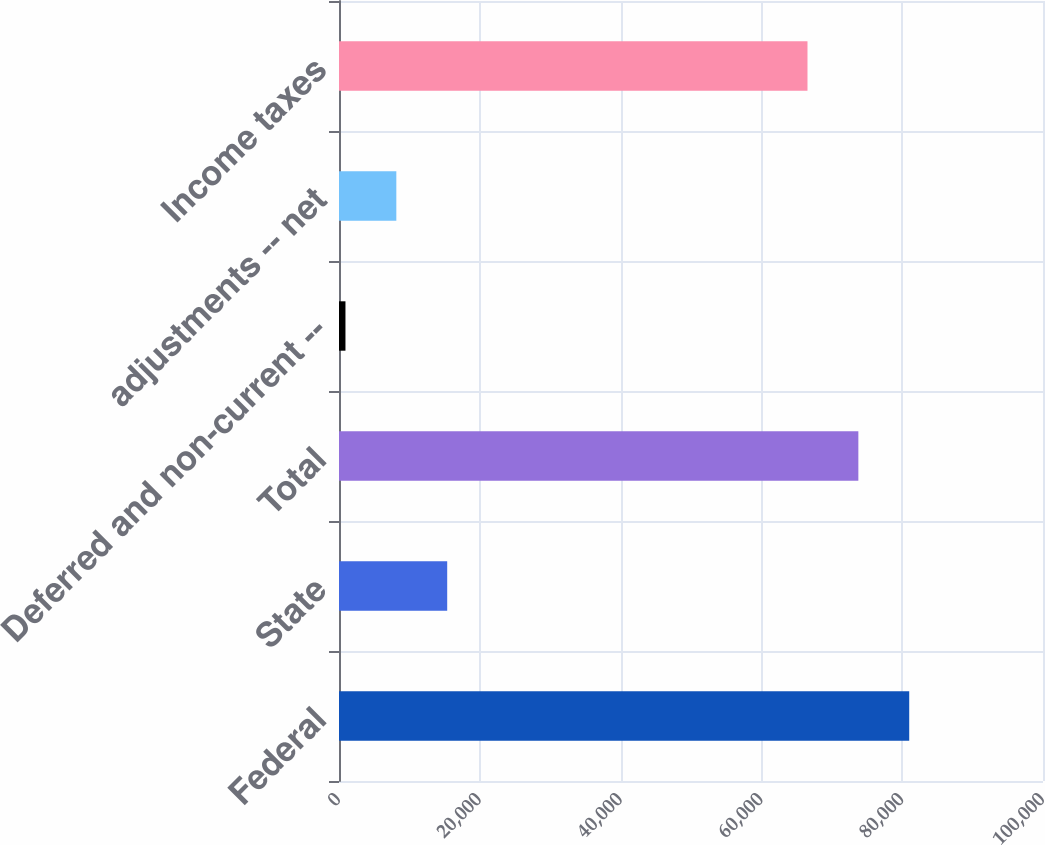<chart> <loc_0><loc_0><loc_500><loc_500><bar_chart><fcel>Federal<fcel>State<fcel>Total<fcel>Deferred and non-current --<fcel>adjustments -- net<fcel>Income taxes<nl><fcel>80997.2<fcel>15369.2<fcel>73771.6<fcel>918<fcel>8143.6<fcel>66546<nl></chart> 